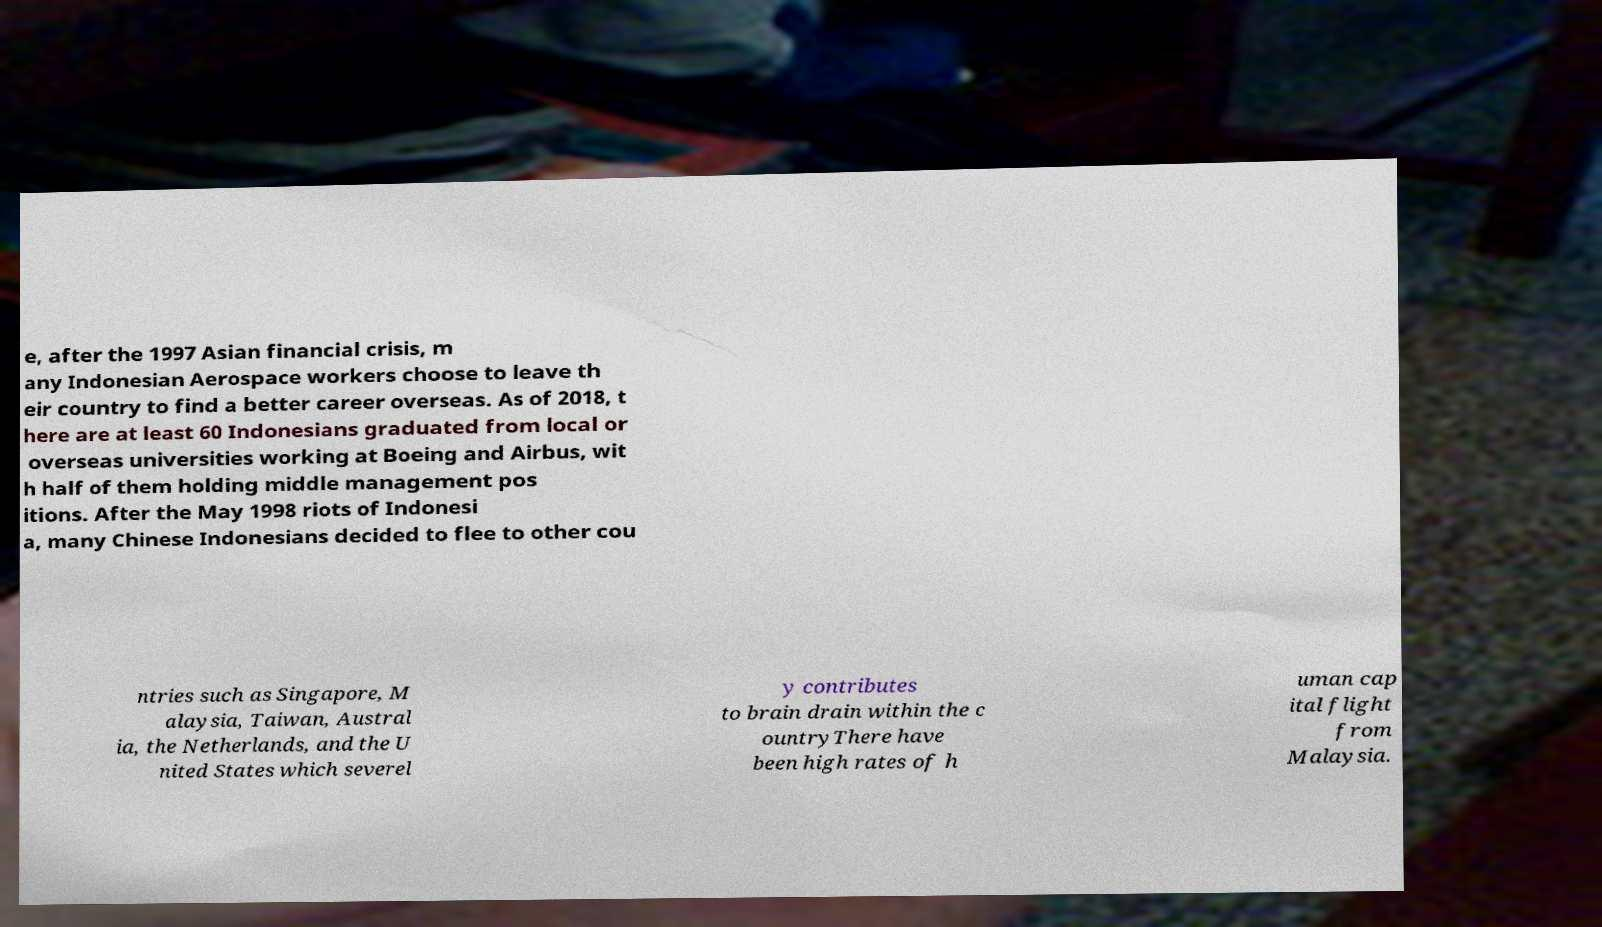Can you read and provide the text displayed in the image?This photo seems to have some interesting text. Can you extract and type it out for me? e, after the 1997 Asian financial crisis, m any Indonesian Aerospace workers choose to leave th eir country to find a better career overseas. As of 2018, t here are at least 60 Indonesians graduated from local or overseas universities working at Boeing and Airbus, wit h half of them holding middle management pos itions. After the May 1998 riots of Indonesi a, many Chinese Indonesians decided to flee to other cou ntries such as Singapore, M alaysia, Taiwan, Austral ia, the Netherlands, and the U nited States which severel y contributes to brain drain within the c ountryThere have been high rates of h uman cap ital flight from Malaysia. 